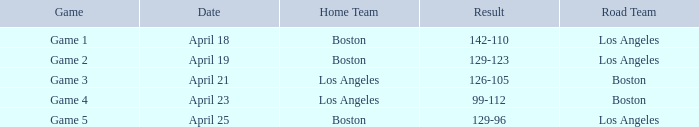WHAT IS THE HOME TEAM, RESULT 99-112? Los Angeles. 